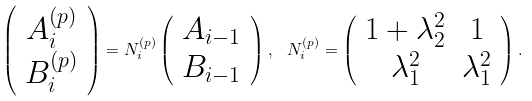Convert formula to latex. <formula><loc_0><loc_0><loc_500><loc_500>\left ( \begin{array} { c } A ^ { ( p ) } _ { i } \\ B ^ { ( p ) } _ { i } \end{array} \right ) = { N } _ { i } ^ { ( p ) } \left ( \begin{array} { c } A _ { i - 1 } \\ B _ { i - 1 } \end{array} \right ) , \ \ { N } _ { i } ^ { ( p ) } = \left ( \begin{array} { c c } 1 + \lambda _ { 2 } ^ { 2 } & 1 \\ \lambda _ { 1 } ^ { 2 } & \lambda _ { 1 } ^ { 2 } \end{array} \right ) .</formula> 